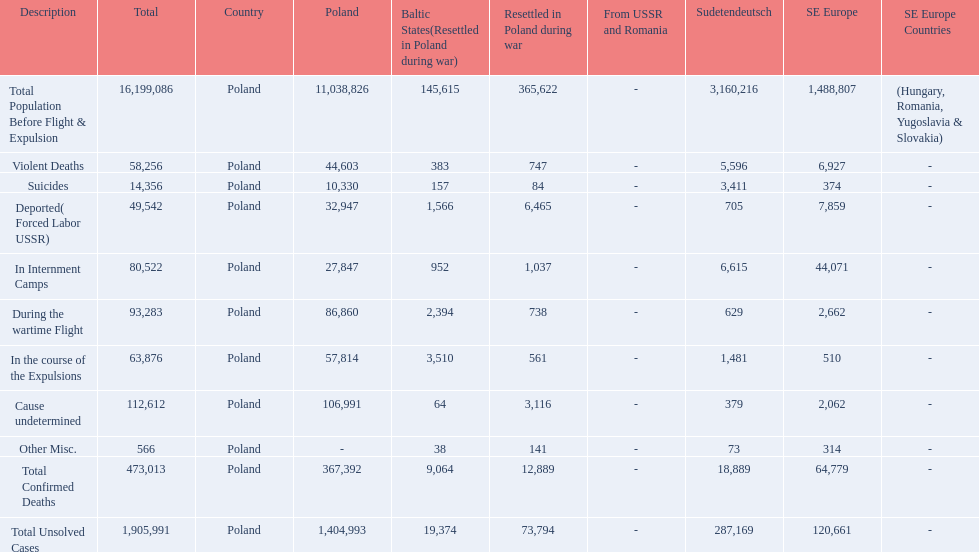What was the cause of the most deaths? Cause undetermined. 